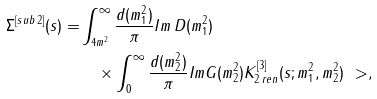Convert formula to latex. <formula><loc_0><loc_0><loc_500><loc_500>\Sigma ^ { [ s u b \, 2 ] } ( s ) = & \int _ { 4 m ^ { 2 } } ^ { \infty } \frac { d ( m _ { 1 } ^ { 2 } ) } { \pi } I m \, D ( m _ { 1 } ^ { 2 } ) \\ & \quad \times \int _ { 0 } ^ { \infty } \frac { d ( m _ { 2 } ^ { 2 } ) } { \pi } I m G ( m _ { 2 } ^ { 2 } ) K ^ { [ 3 ] } _ { 2 \, r e n } ( s ; m _ { 1 } ^ { 2 } , m _ { 2 } ^ { 2 } ) \ > ,</formula> 